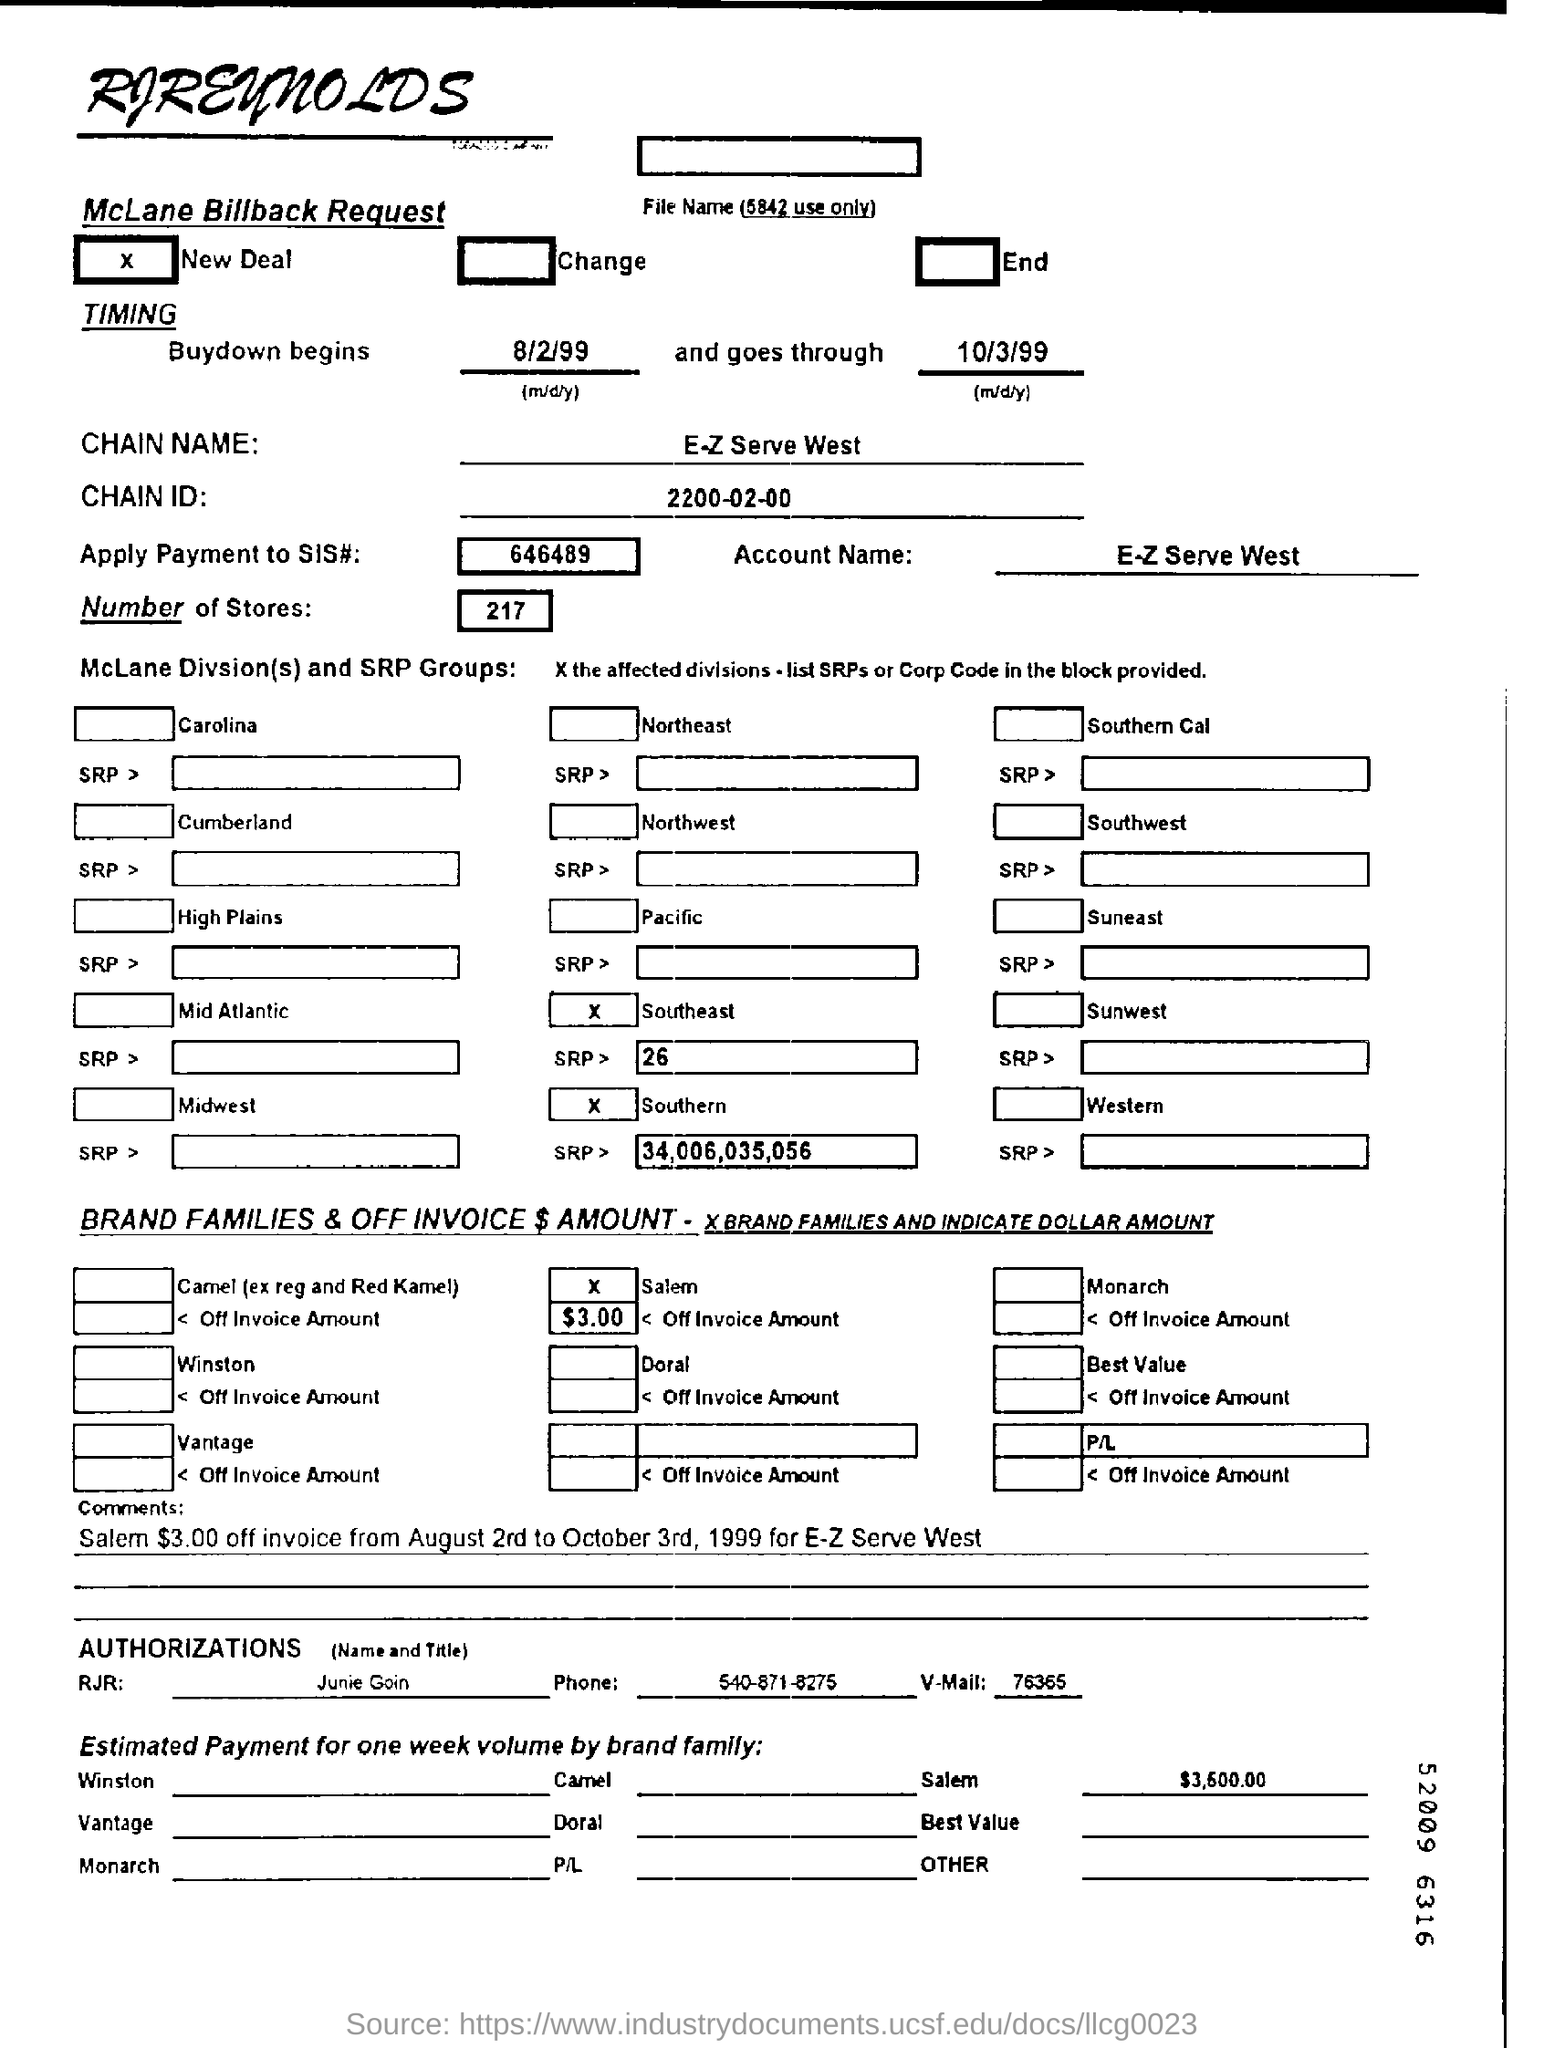When does buydown begin?
Your answer should be compact. 8/2/99. Which company's name is at the top of the page?
Your response must be concise. RJReynolds. What is the chain name?
Provide a short and direct response. E-Z Serve West. What is the chain ID?
Provide a succinct answer. 2200-02-00. What is the apply payment to SIS# ?
Provide a succinct answer. 646489. What is the number of stores?
Your response must be concise. 217. 